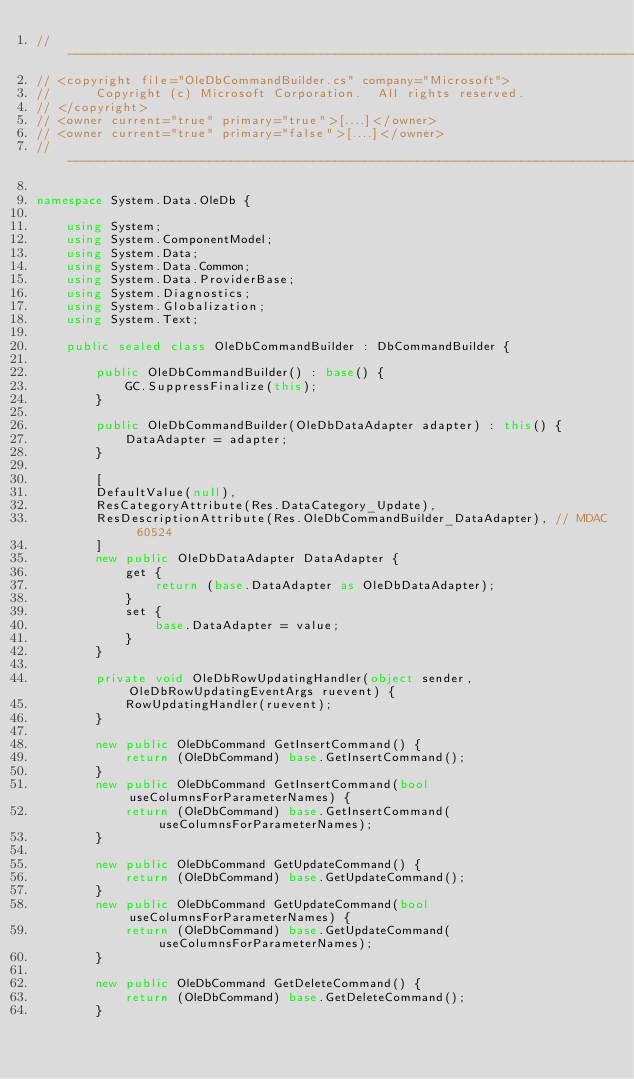Convert code to text. <code><loc_0><loc_0><loc_500><loc_500><_C#_>//------------------------------------------------------------------------------
// <copyright file="OleDbCommandBuilder.cs" company="Microsoft">
//      Copyright (c) Microsoft Corporation.  All rights reserved.
// </copyright>
// <owner current="true" primary="true">[....]</owner>
// <owner current="true" primary="false">[....]</owner>
//------------------------------------------------------------------------------

namespace System.Data.OleDb {

    using System;
    using System.ComponentModel;
    using System.Data;
    using System.Data.Common;
    using System.Data.ProviderBase;
    using System.Diagnostics;
    using System.Globalization;
    using System.Text;

    public sealed class OleDbCommandBuilder : DbCommandBuilder {

        public OleDbCommandBuilder() : base() {
            GC.SuppressFinalize(this);
        }

        public OleDbCommandBuilder(OleDbDataAdapter adapter) : this() {
            DataAdapter = adapter;
        }

        [
        DefaultValue(null),
        ResCategoryAttribute(Res.DataCategory_Update),
        ResDescriptionAttribute(Res.OleDbCommandBuilder_DataAdapter), // MDAC 60524
        ]
        new public OleDbDataAdapter DataAdapter {
            get {
                return (base.DataAdapter as OleDbDataAdapter);
            }
            set {
                base.DataAdapter = value;
            }
        }

        private void OleDbRowUpdatingHandler(object sender, OleDbRowUpdatingEventArgs ruevent) {
            RowUpdatingHandler(ruevent);
        }

        new public OleDbCommand GetInsertCommand() {
            return (OleDbCommand) base.GetInsertCommand();
        }
        new public OleDbCommand GetInsertCommand(bool useColumnsForParameterNames) {
            return (OleDbCommand) base.GetInsertCommand(useColumnsForParameterNames);
        }

        new public OleDbCommand GetUpdateCommand() {
            return (OleDbCommand) base.GetUpdateCommand();
        }
        new public OleDbCommand GetUpdateCommand(bool useColumnsForParameterNames) {
            return (OleDbCommand) base.GetUpdateCommand(useColumnsForParameterNames);
        }

        new public OleDbCommand GetDeleteCommand() {
            return (OleDbCommand) base.GetDeleteCommand();
        }</code> 